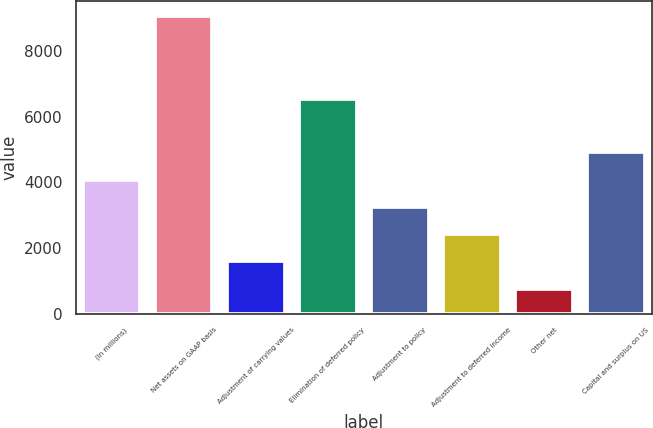<chart> <loc_0><loc_0><loc_500><loc_500><bar_chart><fcel>(In millions)<fcel>Net assets on GAAP basis<fcel>Adjustment of carrying values<fcel>Elimination of deferred policy<fcel>Adjustment to policy<fcel>Adjustment to deferred income<fcel>Other net<fcel>Capital and surplus on US<nl><fcel>4076<fcel>9050<fcel>1589<fcel>6540<fcel>3247<fcel>2418<fcel>760<fcel>4905<nl></chart> 